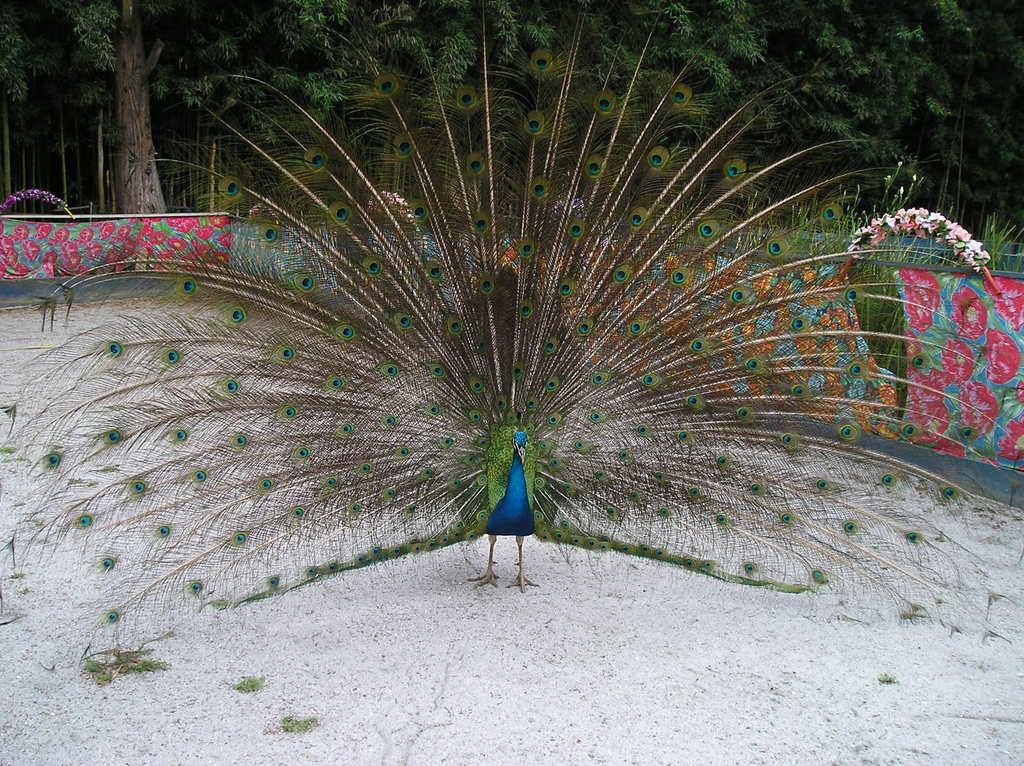What animal is the main subject of the image? There is a peacock in the image. Where is the peacock located in the image? The peacock is at the bottom of the image. What can be seen in the background of the image? There are trees in the background of the image. Can you describe the sense of humor of the woman in the image? There is no woman present in the image, only a peacock and trees in the background. 